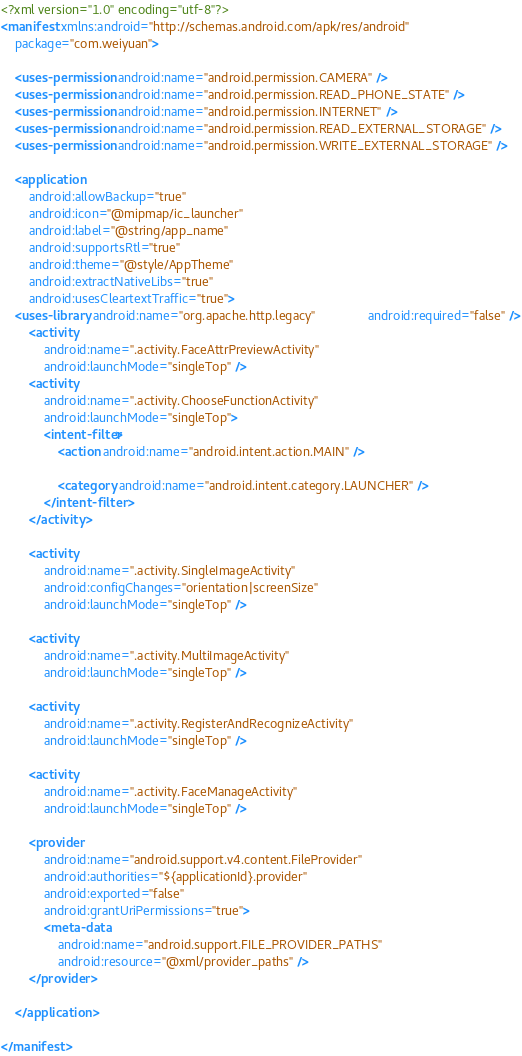<code> <loc_0><loc_0><loc_500><loc_500><_XML_><?xml version="1.0" encoding="utf-8"?>
<manifest xmlns:android="http://schemas.android.com/apk/res/android"
    package="com.weiyuan">

    <uses-permission android:name="android.permission.CAMERA" />
    <uses-permission android:name="android.permission.READ_PHONE_STATE" />
    <uses-permission android:name="android.permission.INTERNET" />
    <uses-permission android:name="android.permission.READ_EXTERNAL_STORAGE" />
    <uses-permission android:name="android.permission.WRITE_EXTERNAL_STORAGE" />

    <application
        android:allowBackup="true"
        android:icon="@mipmap/ic_launcher"
        android:label="@string/app_name"
        android:supportsRtl="true"
        android:theme="@style/AppTheme"
        android:extractNativeLibs="true"
        android:usesCleartextTraffic="true">
    <uses-library android:name="org.apache.http.legacy"               android:required="false" />
        <activity
            android:name=".activity.FaceAttrPreviewActivity"
            android:launchMode="singleTop" />
        <activity
            android:name=".activity.ChooseFunctionActivity"
            android:launchMode="singleTop">
            <intent-filter>
                <action android:name="android.intent.action.MAIN" />

                <category android:name="android.intent.category.LAUNCHER" />
            </intent-filter>
        </activity>

        <activity
            android:name=".activity.SingleImageActivity"
            android:configChanges="orientation|screenSize"
            android:launchMode="singleTop" />

        <activity
            android:name=".activity.MultiImageActivity"
            android:launchMode="singleTop" />

        <activity
            android:name=".activity.RegisterAndRecognizeActivity"
            android:launchMode="singleTop" />

        <activity
            android:name=".activity.FaceManageActivity"
            android:launchMode="singleTop" />

        <provider
            android:name="android.support.v4.content.FileProvider"
            android:authorities="${applicationId}.provider"
            android:exported="false"
            android:grantUriPermissions="true">
            <meta-data
                android:name="android.support.FILE_PROVIDER_PATHS"
                android:resource="@xml/provider_paths" />
        </provider>

    </application>

</manifest></code> 